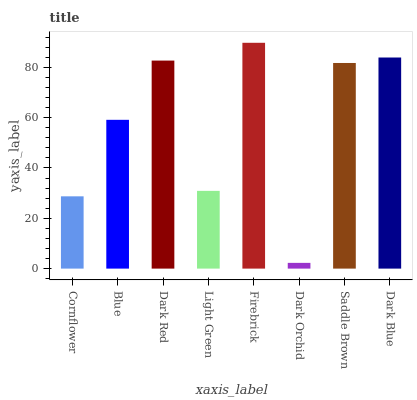Is Dark Orchid the minimum?
Answer yes or no. Yes. Is Firebrick the maximum?
Answer yes or no. Yes. Is Blue the minimum?
Answer yes or no. No. Is Blue the maximum?
Answer yes or no. No. Is Blue greater than Cornflower?
Answer yes or no. Yes. Is Cornflower less than Blue?
Answer yes or no. Yes. Is Cornflower greater than Blue?
Answer yes or no. No. Is Blue less than Cornflower?
Answer yes or no. No. Is Saddle Brown the high median?
Answer yes or no. Yes. Is Blue the low median?
Answer yes or no. Yes. Is Light Green the high median?
Answer yes or no. No. Is Dark Red the low median?
Answer yes or no. No. 